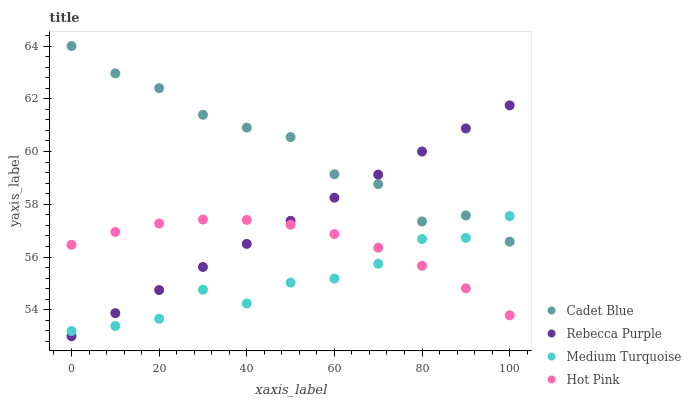Does Medium Turquoise have the minimum area under the curve?
Answer yes or no. Yes. Does Cadet Blue have the maximum area under the curve?
Answer yes or no. Yes. Does Rebecca Purple have the minimum area under the curve?
Answer yes or no. No. Does Rebecca Purple have the maximum area under the curve?
Answer yes or no. No. Is Rebecca Purple the smoothest?
Answer yes or no. Yes. Is Cadet Blue the roughest?
Answer yes or no. Yes. Is Medium Turquoise the smoothest?
Answer yes or no. No. Is Medium Turquoise the roughest?
Answer yes or no. No. Does Rebecca Purple have the lowest value?
Answer yes or no. Yes. Does Medium Turquoise have the lowest value?
Answer yes or no. No. Does Cadet Blue have the highest value?
Answer yes or no. Yes. Does Rebecca Purple have the highest value?
Answer yes or no. No. Is Hot Pink less than Cadet Blue?
Answer yes or no. Yes. Is Cadet Blue greater than Hot Pink?
Answer yes or no. Yes. Does Medium Turquoise intersect Hot Pink?
Answer yes or no. Yes. Is Medium Turquoise less than Hot Pink?
Answer yes or no. No. Is Medium Turquoise greater than Hot Pink?
Answer yes or no. No. Does Hot Pink intersect Cadet Blue?
Answer yes or no. No. 